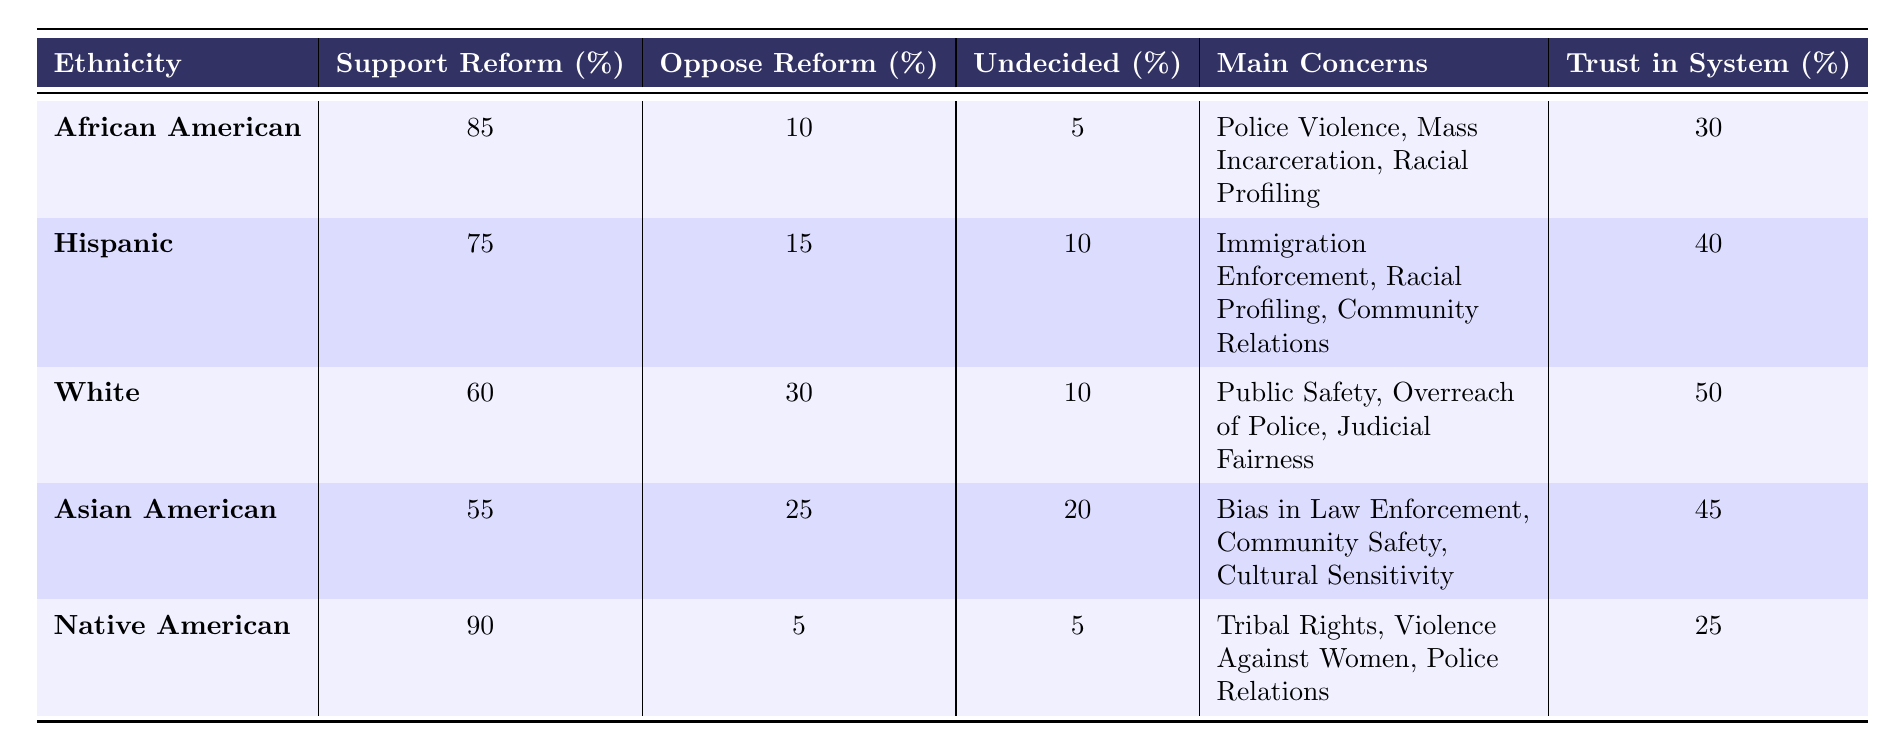What percentage of African Americans support criminal justice reform? The table shows that 85% of African Americans support criminal justice reform.
Answer: 85% What is the main concern for the Hispanic community regarding criminal justice reform? According to the table, the main concerns for the Hispanic community are Immigration Enforcement, Racial Profiling, and Community Relations.
Answer: Immigration Enforcement, Racial Profiling, Community Relations Which ethnicity has the highest percentage of undecided individuals regarding reform? The Asian American group has the highest percentage of undecided individuals with 20%.
Answer: 20% What is the difference between the support for reform among Native Americans and White individuals? Native Americans support reform at 90%, while White individuals support it at 60%. The difference is 90% - 60% = 30%.
Answer: 30% What percentage of the White community opposes criminal justice reform? The table indicates that 30% of the White community opposes criminal justice reform.
Answer: 30% Is there a lower percentage of support for reform among Asians than among Hispanics? Yes, Asian Americans support reform at 55%, which is lower than the 75% support among Hispanics.
Answer: Yes What is the average trust in the criminal justice system across all ethnicities listed? To find the average trust, sum the trust percentages: 30 + 40 + 50 + 45 + 25 = 190. There are 5 groups, so the average is 190 / 5 = 38.
Answer: 38 Which ethnic group has the least trust in the criminal justice system? The table shows that Native Americans have the least trust in the system with 25%.
Answer: 25% How many ethnicities have more than 70% support for reform? Two ethnicities, African American (85%) and Native American (90%), have over 70% support for reform.
Answer: 2 What can be inferred about the concerns regarding police relations from different ethnic groups? African Americans and Native Americans both express concerns over police relations, while the White and Asian American groups mention judicial fairness and bias, respectively, indicating varied perspectives on police relations.
Answer: Varied perspectives exist 